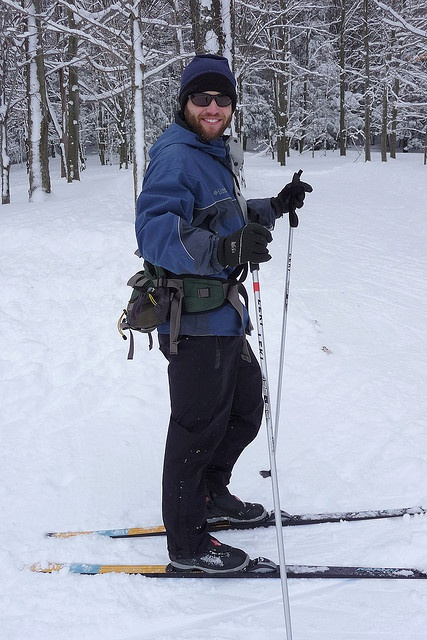Describe the objects in this image and their specific colors. I can see people in black, navy, darkblue, and gray tones, skis in black, lavender, darkgray, and gray tones, and backpack in black and gray tones in this image. 